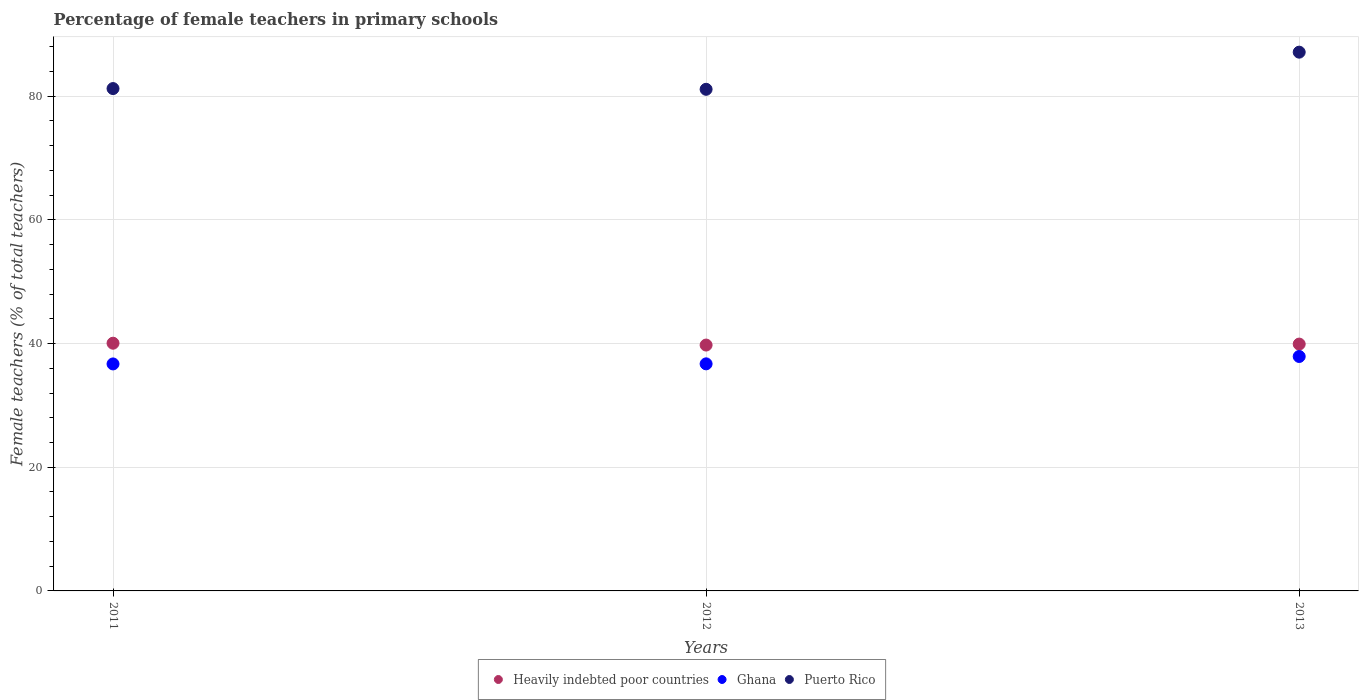How many different coloured dotlines are there?
Ensure brevity in your answer.  3. Is the number of dotlines equal to the number of legend labels?
Your response must be concise. Yes. What is the percentage of female teachers in Ghana in 2012?
Keep it short and to the point. 36.72. Across all years, what is the maximum percentage of female teachers in Puerto Rico?
Your answer should be very brief. 87.13. Across all years, what is the minimum percentage of female teachers in Puerto Rico?
Offer a terse response. 81.12. What is the total percentage of female teachers in Puerto Rico in the graph?
Make the answer very short. 249.49. What is the difference between the percentage of female teachers in Heavily indebted poor countries in 2011 and that in 2012?
Ensure brevity in your answer.  0.3. What is the difference between the percentage of female teachers in Heavily indebted poor countries in 2013 and the percentage of female teachers in Ghana in 2012?
Your answer should be compact. 3.2. What is the average percentage of female teachers in Puerto Rico per year?
Offer a terse response. 83.16. In the year 2013, what is the difference between the percentage of female teachers in Puerto Rico and percentage of female teachers in Ghana?
Ensure brevity in your answer.  49.22. In how many years, is the percentage of female teachers in Heavily indebted poor countries greater than 12 %?
Provide a succinct answer. 3. What is the ratio of the percentage of female teachers in Puerto Rico in 2012 to that in 2013?
Provide a succinct answer. 0.93. Is the percentage of female teachers in Heavily indebted poor countries in 2012 less than that in 2013?
Ensure brevity in your answer.  Yes. What is the difference between the highest and the second highest percentage of female teachers in Ghana?
Your answer should be compact. 1.19. What is the difference between the highest and the lowest percentage of female teachers in Ghana?
Provide a short and direct response. 1.2. In how many years, is the percentage of female teachers in Puerto Rico greater than the average percentage of female teachers in Puerto Rico taken over all years?
Your response must be concise. 1. Is the sum of the percentage of female teachers in Heavily indebted poor countries in 2012 and 2013 greater than the maximum percentage of female teachers in Ghana across all years?
Your answer should be very brief. Yes. What is the difference between two consecutive major ticks on the Y-axis?
Provide a succinct answer. 20. Are the values on the major ticks of Y-axis written in scientific E-notation?
Provide a short and direct response. No. Does the graph contain any zero values?
Your answer should be very brief. No. Does the graph contain grids?
Your answer should be compact. Yes. Where does the legend appear in the graph?
Offer a terse response. Bottom center. How are the legend labels stacked?
Your answer should be compact. Horizontal. What is the title of the graph?
Offer a terse response. Percentage of female teachers in primary schools. What is the label or title of the X-axis?
Provide a short and direct response. Years. What is the label or title of the Y-axis?
Ensure brevity in your answer.  Female teachers (% of total teachers). What is the Female teachers (% of total teachers) in Heavily indebted poor countries in 2011?
Keep it short and to the point. 40.06. What is the Female teachers (% of total teachers) in Ghana in 2011?
Your response must be concise. 36.71. What is the Female teachers (% of total teachers) in Puerto Rico in 2011?
Your answer should be compact. 81.24. What is the Female teachers (% of total teachers) of Heavily indebted poor countries in 2012?
Provide a succinct answer. 39.76. What is the Female teachers (% of total teachers) in Ghana in 2012?
Give a very brief answer. 36.72. What is the Female teachers (% of total teachers) in Puerto Rico in 2012?
Offer a very short reply. 81.12. What is the Female teachers (% of total teachers) of Heavily indebted poor countries in 2013?
Offer a very short reply. 39.92. What is the Female teachers (% of total teachers) of Ghana in 2013?
Ensure brevity in your answer.  37.91. What is the Female teachers (% of total teachers) of Puerto Rico in 2013?
Your response must be concise. 87.13. Across all years, what is the maximum Female teachers (% of total teachers) in Heavily indebted poor countries?
Keep it short and to the point. 40.06. Across all years, what is the maximum Female teachers (% of total teachers) in Ghana?
Your answer should be compact. 37.91. Across all years, what is the maximum Female teachers (% of total teachers) of Puerto Rico?
Offer a very short reply. 87.13. Across all years, what is the minimum Female teachers (% of total teachers) in Heavily indebted poor countries?
Your response must be concise. 39.76. Across all years, what is the minimum Female teachers (% of total teachers) in Ghana?
Ensure brevity in your answer.  36.71. Across all years, what is the minimum Female teachers (% of total teachers) in Puerto Rico?
Your answer should be very brief. 81.12. What is the total Female teachers (% of total teachers) of Heavily indebted poor countries in the graph?
Ensure brevity in your answer.  119.74. What is the total Female teachers (% of total teachers) in Ghana in the graph?
Provide a succinct answer. 111.34. What is the total Female teachers (% of total teachers) in Puerto Rico in the graph?
Offer a very short reply. 249.49. What is the difference between the Female teachers (% of total teachers) of Heavily indebted poor countries in 2011 and that in 2012?
Offer a very short reply. 0.3. What is the difference between the Female teachers (% of total teachers) in Ghana in 2011 and that in 2012?
Provide a succinct answer. -0.01. What is the difference between the Female teachers (% of total teachers) of Puerto Rico in 2011 and that in 2012?
Keep it short and to the point. 0.12. What is the difference between the Female teachers (% of total teachers) of Heavily indebted poor countries in 2011 and that in 2013?
Provide a short and direct response. 0.14. What is the difference between the Female teachers (% of total teachers) of Ghana in 2011 and that in 2013?
Ensure brevity in your answer.  -1.2. What is the difference between the Female teachers (% of total teachers) of Puerto Rico in 2011 and that in 2013?
Your response must be concise. -5.89. What is the difference between the Female teachers (% of total teachers) in Heavily indebted poor countries in 2012 and that in 2013?
Provide a succinct answer. -0.16. What is the difference between the Female teachers (% of total teachers) of Ghana in 2012 and that in 2013?
Make the answer very short. -1.19. What is the difference between the Female teachers (% of total teachers) in Puerto Rico in 2012 and that in 2013?
Give a very brief answer. -6.01. What is the difference between the Female teachers (% of total teachers) in Heavily indebted poor countries in 2011 and the Female teachers (% of total teachers) in Ghana in 2012?
Your response must be concise. 3.34. What is the difference between the Female teachers (% of total teachers) in Heavily indebted poor countries in 2011 and the Female teachers (% of total teachers) in Puerto Rico in 2012?
Give a very brief answer. -41.06. What is the difference between the Female teachers (% of total teachers) in Ghana in 2011 and the Female teachers (% of total teachers) in Puerto Rico in 2012?
Make the answer very short. -44.41. What is the difference between the Female teachers (% of total teachers) of Heavily indebted poor countries in 2011 and the Female teachers (% of total teachers) of Ghana in 2013?
Offer a very short reply. 2.15. What is the difference between the Female teachers (% of total teachers) in Heavily indebted poor countries in 2011 and the Female teachers (% of total teachers) in Puerto Rico in 2013?
Offer a very short reply. -47.07. What is the difference between the Female teachers (% of total teachers) in Ghana in 2011 and the Female teachers (% of total teachers) in Puerto Rico in 2013?
Your response must be concise. -50.42. What is the difference between the Female teachers (% of total teachers) in Heavily indebted poor countries in 2012 and the Female teachers (% of total teachers) in Ghana in 2013?
Keep it short and to the point. 1.85. What is the difference between the Female teachers (% of total teachers) of Heavily indebted poor countries in 2012 and the Female teachers (% of total teachers) of Puerto Rico in 2013?
Keep it short and to the point. -47.37. What is the difference between the Female teachers (% of total teachers) in Ghana in 2012 and the Female teachers (% of total teachers) in Puerto Rico in 2013?
Offer a terse response. -50.41. What is the average Female teachers (% of total teachers) of Heavily indebted poor countries per year?
Provide a short and direct response. 39.91. What is the average Female teachers (% of total teachers) of Ghana per year?
Provide a short and direct response. 37.11. What is the average Female teachers (% of total teachers) in Puerto Rico per year?
Offer a very short reply. 83.16. In the year 2011, what is the difference between the Female teachers (% of total teachers) in Heavily indebted poor countries and Female teachers (% of total teachers) in Ghana?
Ensure brevity in your answer.  3.35. In the year 2011, what is the difference between the Female teachers (% of total teachers) of Heavily indebted poor countries and Female teachers (% of total teachers) of Puerto Rico?
Your response must be concise. -41.18. In the year 2011, what is the difference between the Female teachers (% of total teachers) in Ghana and Female teachers (% of total teachers) in Puerto Rico?
Provide a short and direct response. -44.53. In the year 2012, what is the difference between the Female teachers (% of total teachers) of Heavily indebted poor countries and Female teachers (% of total teachers) of Ghana?
Your response must be concise. 3.04. In the year 2012, what is the difference between the Female teachers (% of total teachers) in Heavily indebted poor countries and Female teachers (% of total teachers) in Puerto Rico?
Offer a very short reply. -41.36. In the year 2012, what is the difference between the Female teachers (% of total teachers) of Ghana and Female teachers (% of total teachers) of Puerto Rico?
Keep it short and to the point. -44.4. In the year 2013, what is the difference between the Female teachers (% of total teachers) of Heavily indebted poor countries and Female teachers (% of total teachers) of Ghana?
Offer a very short reply. 2.01. In the year 2013, what is the difference between the Female teachers (% of total teachers) of Heavily indebted poor countries and Female teachers (% of total teachers) of Puerto Rico?
Give a very brief answer. -47.21. In the year 2013, what is the difference between the Female teachers (% of total teachers) in Ghana and Female teachers (% of total teachers) in Puerto Rico?
Provide a short and direct response. -49.22. What is the ratio of the Female teachers (% of total teachers) in Heavily indebted poor countries in 2011 to that in 2012?
Give a very brief answer. 1.01. What is the ratio of the Female teachers (% of total teachers) in Ghana in 2011 to that in 2012?
Provide a short and direct response. 1. What is the ratio of the Female teachers (% of total teachers) of Ghana in 2011 to that in 2013?
Your answer should be very brief. 0.97. What is the ratio of the Female teachers (% of total teachers) of Puerto Rico in 2011 to that in 2013?
Provide a short and direct response. 0.93. What is the ratio of the Female teachers (% of total teachers) of Ghana in 2012 to that in 2013?
Your answer should be very brief. 0.97. What is the ratio of the Female teachers (% of total teachers) of Puerto Rico in 2012 to that in 2013?
Offer a terse response. 0.93. What is the difference between the highest and the second highest Female teachers (% of total teachers) in Heavily indebted poor countries?
Provide a succinct answer. 0.14. What is the difference between the highest and the second highest Female teachers (% of total teachers) in Ghana?
Offer a very short reply. 1.19. What is the difference between the highest and the second highest Female teachers (% of total teachers) in Puerto Rico?
Your answer should be very brief. 5.89. What is the difference between the highest and the lowest Female teachers (% of total teachers) of Heavily indebted poor countries?
Offer a very short reply. 0.3. What is the difference between the highest and the lowest Female teachers (% of total teachers) of Ghana?
Your answer should be very brief. 1.2. What is the difference between the highest and the lowest Female teachers (% of total teachers) of Puerto Rico?
Your answer should be very brief. 6.01. 